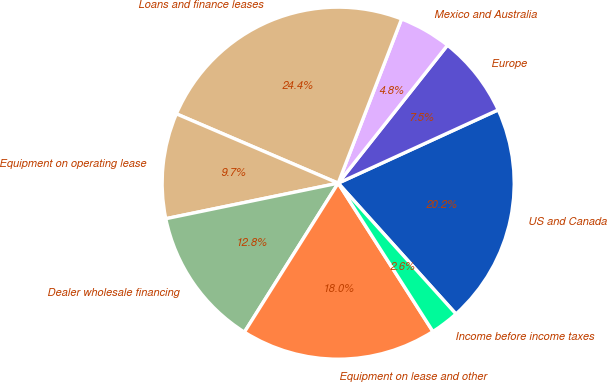Convert chart. <chart><loc_0><loc_0><loc_500><loc_500><pie_chart><fcel>US and Canada<fcel>Europe<fcel>Mexico and Australia<fcel>Loans and finance leases<fcel>Equipment on operating lease<fcel>Dealer wholesale financing<fcel>Equipment on lease and other<fcel>Income before income taxes<nl><fcel>20.17%<fcel>7.5%<fcel>4.8%<fcel>24.42%<fcel>9.68%<fcel>12.82%<fcel>17.99%<fcel>2.62%<nl></chart> 